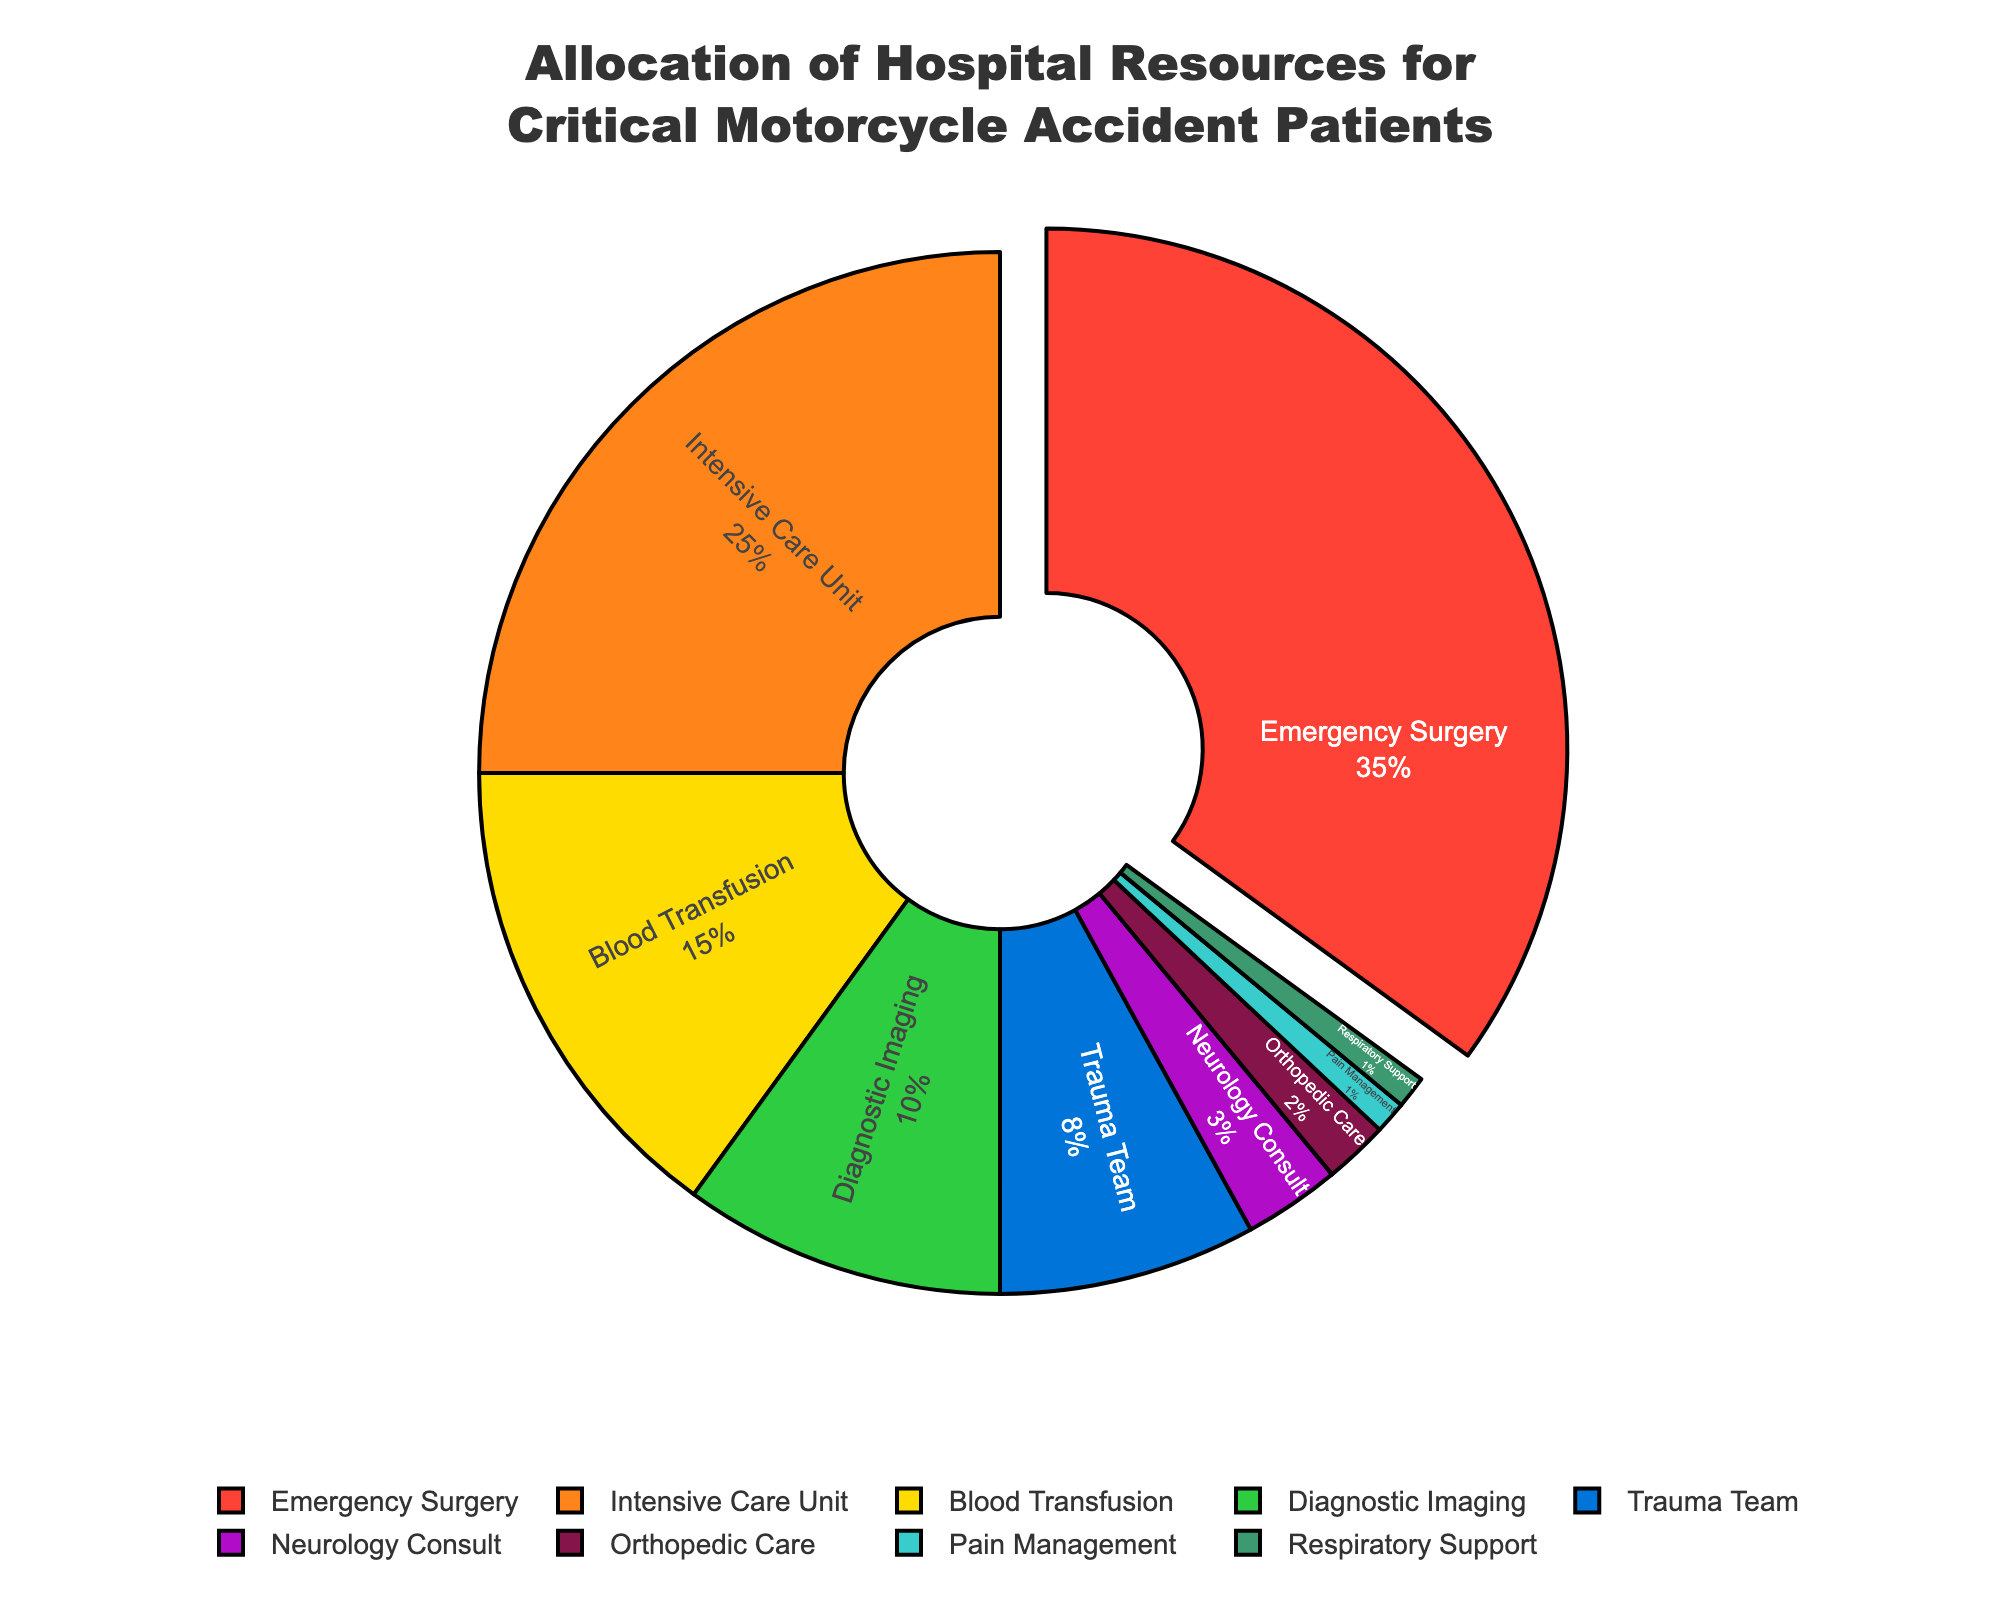What is the largest allocation of hospital resources? The largest allocation of hospital resources goes to Emergency Surgery, which is 35%. The pie chart emphasizes this by pulling the slice out and using a distinct color.
Answer: Emergency Surgery (35%) Which resource has a higher allocation, Diagnostic Imaging or Intensive Care Unit? Comparing the slices, Diagnostic Imaging has 10% while Intensive Care Unit has 25%. Therefore, Intensive Care Unit has a higher allocation.
Answer: Intensive Care Unit What is the combined percentage for Blood Transfusion and Trauma Team? Blood Transfusion is 15% and Trauma Team is 8%. Adding these together: 15% + 8% = 23%
Answer: 23% What two resources have the same percentage allocation? On the pie chart, both Pain Management and Respiratory Support have a 1% allocation each.
Answer: Pain Management and Respiratory Support Which resource has the smallest allocation? The pie chart shows that Pain Management and Respiratory Support each have the smallest allocations of 1%.
Answer: Pain Management and Respiratory Support How much more allocation does Emergency Surgery have compared to Blood Transfusion? Emergency Surgery is allocated 35%, while Blood Transfusion is 15%. To find the difference, subtract 15% from 35%: 35% - 15% = 20%.
Answer: 20% How does Neurology Consult compare to Orthopedic Care in terms of allocated resources? Neurology Consult is allocated 3%, whereas Orthopedic Care is allocated 2%. Neurology Consult has a 1% higher allocation than Orthopedic Care.
Answer: Neurology Consult What is the percentage allocation for resources that are less than 10% each? The resources with allocations less than 10% are Trauma Team (8%), Neurology Consult (3%), Orthopedic Care (2%), Pain Management (1%), and Respiratory Support (1%). Adding these percentages: 8% + 3% + 2% + 1% + 1% = 15%
Answer: 15% Which color represents Intensive Care Unit in the pie chart? The pie chart uses distinct colors for different slices. Intensive Care Unit is represented by the second slice, which is often mapped to an orange color.
Answer: Orange 